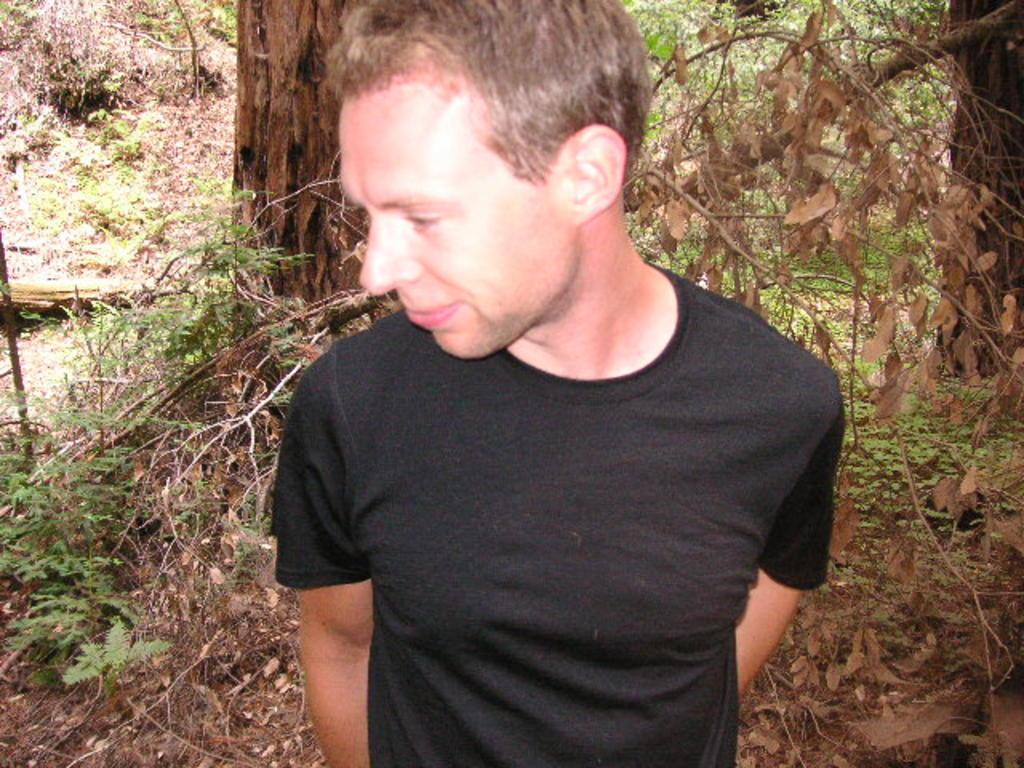Who is present in the image? There is a man in the image. What is the man wearing? The man is wearing a black t-shirt. What can be seen in the background of the image? There are trees and plants in the background of the image. What type of kitten is the man holding in the image? There is no kitten present in the image; the man is not holding anything. How old is the man's daughter in the image? There is no daughter present in the image, so it is not possible to determine her age. 